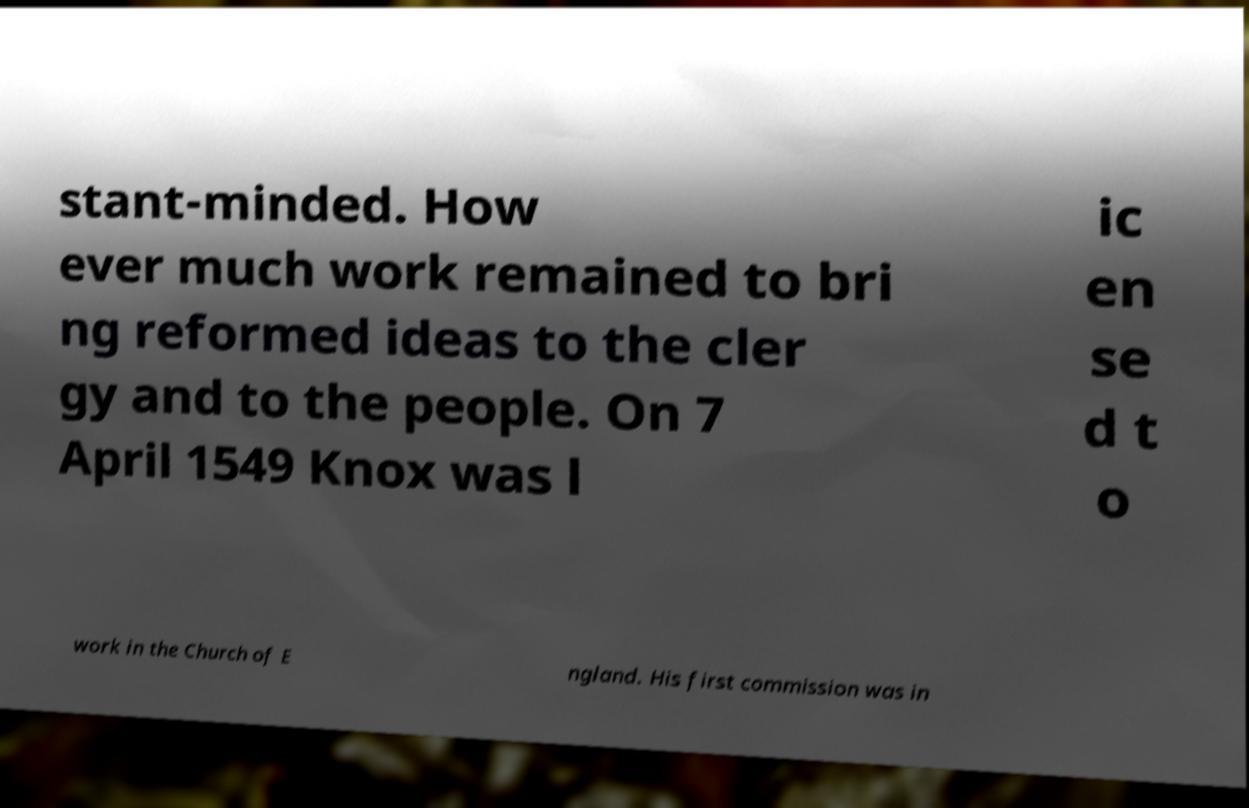What messages or text are displayed in this image? I need them in a readable, typed format. stant-minded. How ever much work remained to bri ng reformed ideas to the cler gy and to the people. On 7 April 1549 Knox was l ic en se d t o work in the Church of E ngland. His first commission was in 